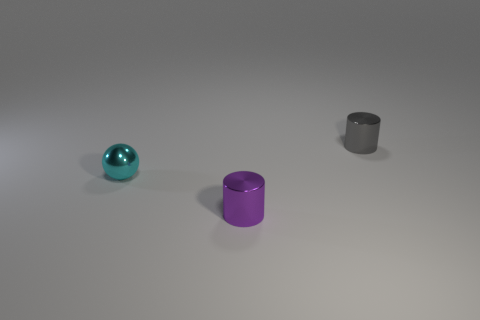Add 2 shiny spheres. How many objects exist? 5 Subtract all balls. How many objects are left? 2 Add 1 cylinders. How many cylinders are left? 3 Add 2 tiny shiny balls. How many tiny shiny balls exist? 3 Subtract 0 blue blocks. How many objects are left? 3 Subtract all tiny purple cylinders. Subtract all gray cylinders. How many objects are left? 1 